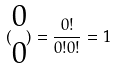<formula> <loc_0><loc_0><loc_500><loc_500>( \begin{matrix} 0 \\ 0 \end{matrix} ) = \frac { 0 ! } { 0 ! 0 ! } = 1</formula> 